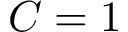<formula> <loc_0><loc_0><loc_500><loc_500>C = 1</formula> 